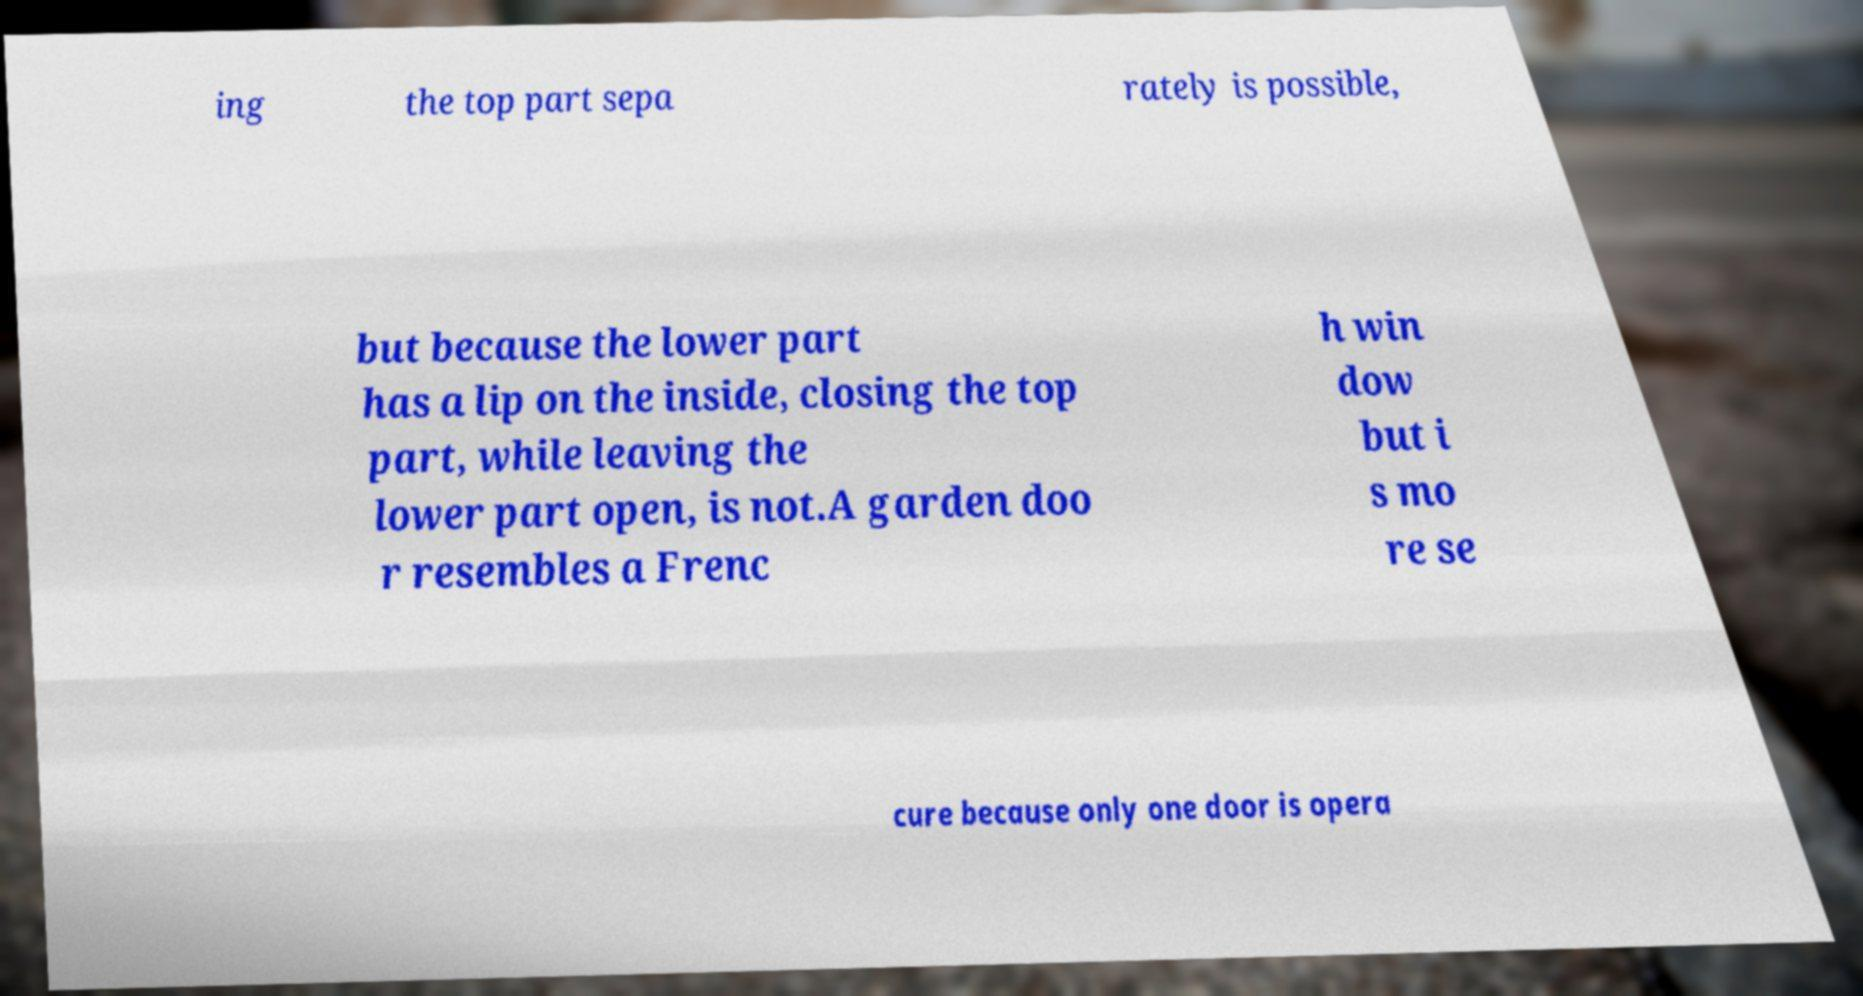There's text embedded in this image that I need extracted. Can you transcribe it verbatim? ing the top part sepa rately is possible, but because the lower part has a lip on the inside, closing the top part, while leaving the lower part open, is not.A garden doo r resembles a Frenc h win dow but i s mo re se cure because only one door is opera 